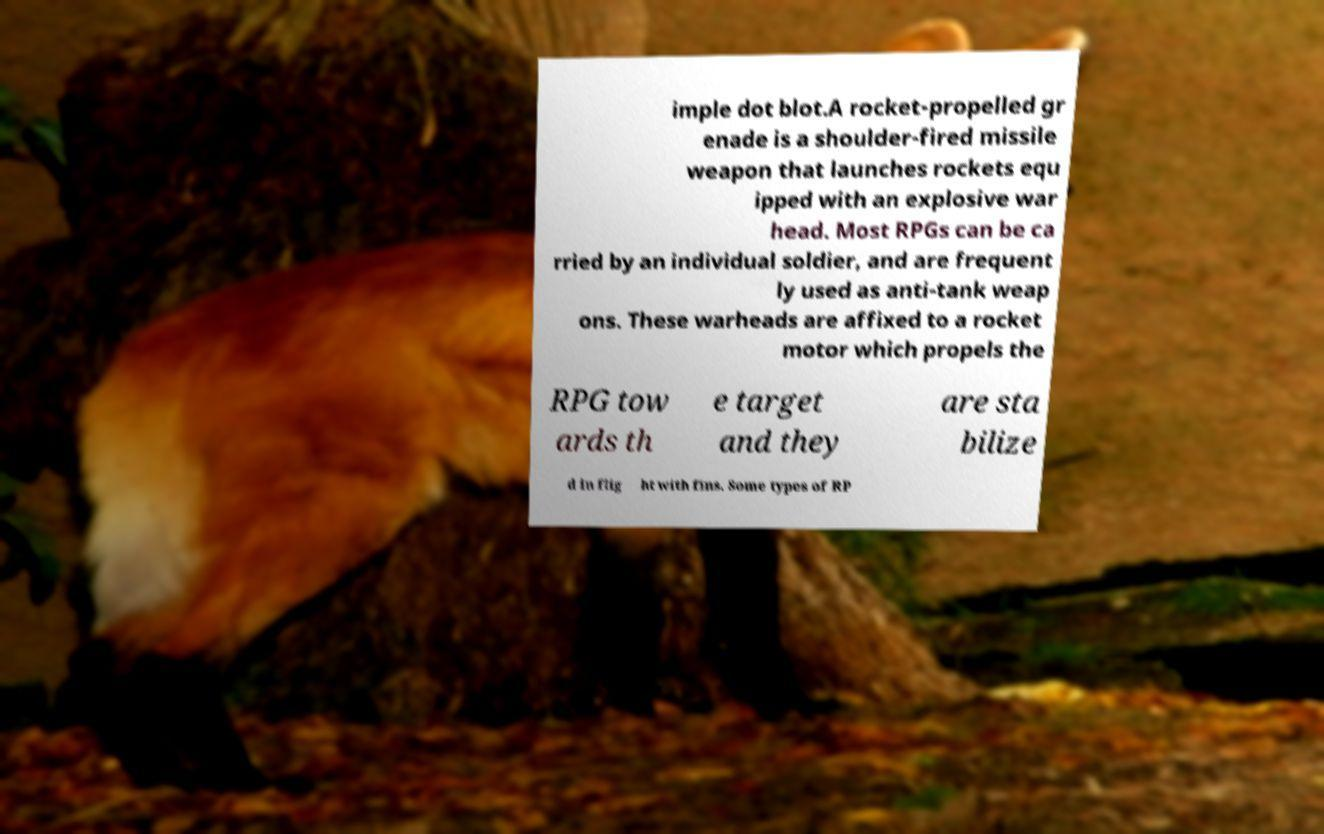Could you assist in decoding the text presented in this image and type it out clearly? imple dot blot.A rocket-propelled gr enade is a shoulder-fired missile weapon that launches rockets equ ipped with an explosive war head. Most RPGs can be ca rried by an individual soldier, and are frequent ly used as anti-tank weap ons. These warheads are affixed to a rocket motor which propels the RPG tow ards th e target and they are sta bilize d in flig ht with fins. Some types of RP 